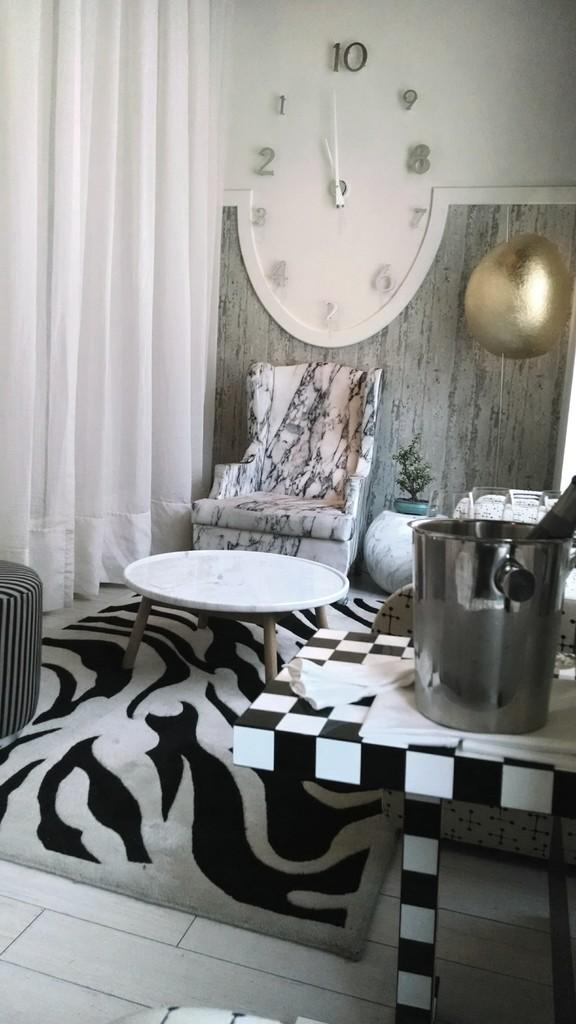<image>
Offer a succinct explanation of the picture presented. a couch sitting with a clock that reads ten above it 